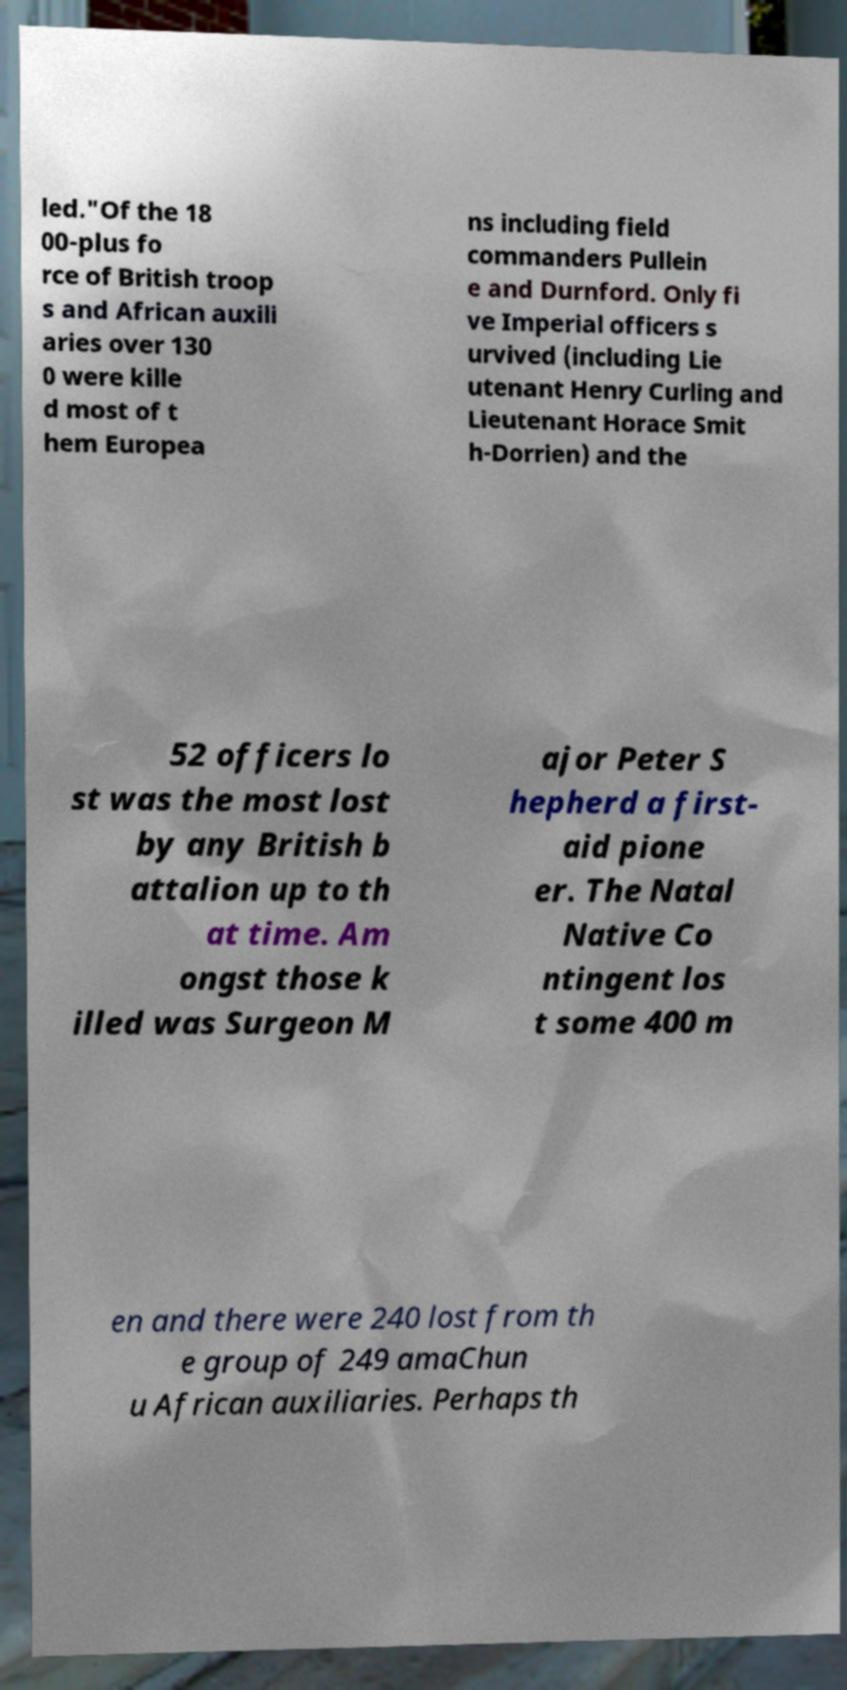I need the written content from this picture converted into text. Can you do that? led."Of the 18 00-plus fo rce of British troop s and African auxili aries over 130 0 were kille d most of t hem Europea ns including field commanders Pullein e and Durnford. Only fi ve Imperial officers s urvived (including Lie utenant Henry Curling and Lieutenant Horace Smit h-Dorrien) and the 52 officers lo st was the most lost by any British b attalion up to th at time. Am ongst those k illed was Surgeon M ajor Peter S hepherd a first- aid pione er. The Natal Native Co ntingent los t some 400 m en and there were 240 lost from th e group of 249 amaChun u African auxiliaries. Perhaps th 